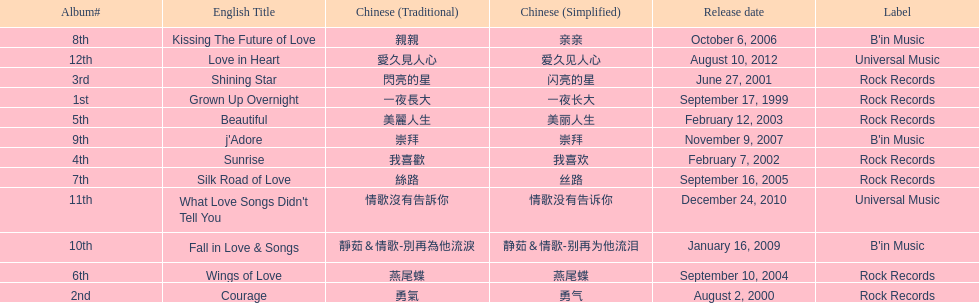Which song is listed first in the table? Grown Up Overnight. 